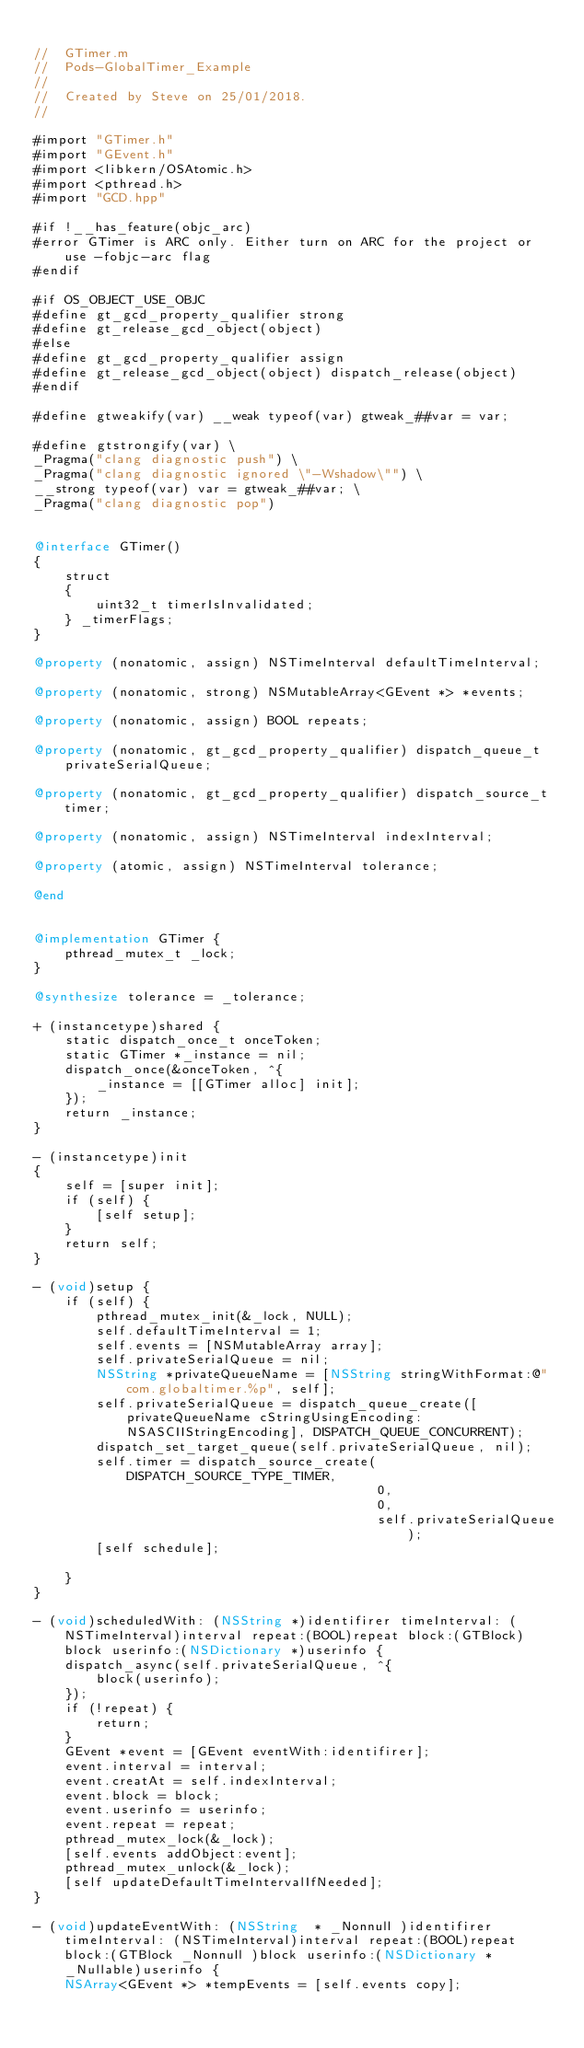<code> <loc_0><loc_0><loc_500><loc_500><_ObjectiveC_>
//  GTimer.m
//  Pods-GlobalTimer_Example
//
//  Created by Steve on 25/01/2018.
//

#import "GTimer.h"
#import "GEvent.h"
#import <libkern/OSAtomic.h>
#import <pthread.h>
#import "GCD.hpp"

#if !__has_feature(objc_arc)
#error GTimer is ARC only. Either turn on ARC for the project or use -fobjc-arc flag
#endif

#if OS_OBJECT_USE_OBJC
#define gt_gcd_property_qualifier strong
#define gt_release_gcd_object(object)
#else
#define gt_gcd_property_qualifier assign
#define gt_release_gcd_object(object) dispatch_release(object)
#endif

#define gtweakify(var) __weak typeof(var) gtweak_##var = var;

#define gtstrongify(var) \
_Pragma("clang diagnostic push") \
_Pragma("clang diagnostic ignored \"-Wshadow\"") \
__strong typeof(var) var = gtweak_##var; \
_Pragma("clang diagnostic pop")


@interface GTimer()
{
    struct
    {
        uint32_t timerIsInvalidated;
    } _timerFlags;
}

@property (nonatomic, assign) NSTimeInterval defaultTimeInterval;

@property (nonatomic, strong) NSMutableArray<GEvent *> *events;

@property (nonatomic, assign) BOOL repeats;

@property (nonatomic, gt_gcd_property_qualifier) dispatch_queue_t privateSerialQueue;

@property (nonatomic, gt_gcd_property_qualifier) dispatch_source_t timer;

@property (nonatomic, assign) NSTimeInterval indexInterval;

@property (atomic, assign) NSTimeInterval tolerance;

@end


@implementation GTimer {
    pthread_mutex_t _lock;
}

@synthesize tolerance = _tolerance;

+ (instancetype)shared {
    static dispatch_once_t onceToken;
    static GTimer *_instance = nil;
    dispatch_once(&onceToken, ^{
        _instance = [[GTimer alloc] init];
    });
    return _instance;
}

- (instancetype)init
{
    self = [super init];
    if (self) {
        [self setup];
    }
    return self;
}

- (void)setup {
    if (self) {
        pthread_mutex_init(&_lock, NULL);
        self.defaultTimeInterval = 1;
        self.events = [NSMutableArray array];
        self.privateSerialQueue = nil;
        NSString *privateQueueName = [NSString stringWithFormat:@"com.globaltimer.%p", self];
        self.privateSerialQueue = dispatch_queue_create([privateQueueName cStringUsingEncoding:NSASCIIStringEncoding], DISPATCH_QUEUE_CONCURRENT);
        dispatch_set_target_queue(self.privateSerialQueue, nil);
        self.timer = dispatch_source_create(DISPATCH_SOURCE_TYPE_TIMER,
                                            0,
                                            0,
                                            self.privateSerialQueue);
        [self schedule];
        
    }
}

- (void)scheduledWith: (NSString *)identifirer timeInterval: (NSTimeInterval)interval repeat:(BOOL)repeat block:(GTBlock)block userinfo:(NSDictionary *)userinfo {
    dispatch_async(self.privateSerialQueue, ^{
        block(userinfo);
    });
    if (!repeat) {
        return;
    }
    GEvent *event = [GEvent eventWith:identifirer];
    event.interval = interval;
    event.creatAt = self.indexInterval;
    event.block = block;
    event.userinfo = userinfo;
    event.repeat = repeat;
    pthread_mutex_lock(&_lock);
    [self.events addObject:event];
    pthread_mutex_unlock(&_lock);
    [self updateDefaultTimeIntervalIfNeeded];
}

- (void)updateEventWith: (NSString  * _Nonnull )identifirer timeInterval: (NSTimeInterval)interval repeat:(BOOL)repeat block:(GTBlock _Nonnull )block userinfo:(NSDictionary * _Nullable)userinfo {
    NSArray<GEvent *> *tempEvents = [self.events copy];</code> 